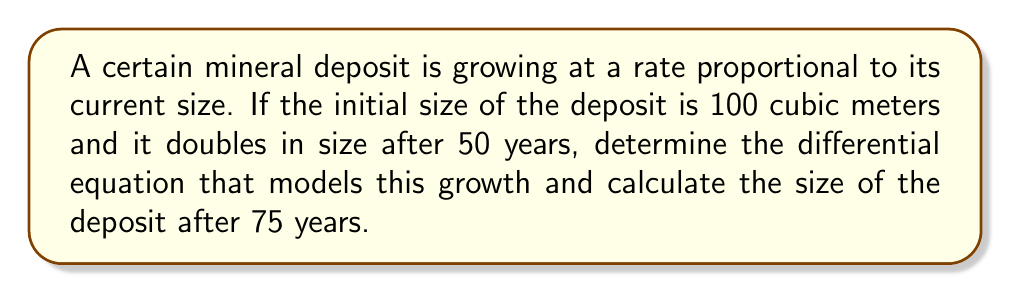Provide a solution to this math problem. Let's approach this step-by-step:

1) Let $V(t)$ be the volume of the deposit at time $t$ in years.

2) The growth rate is proportional to the current size, so we can write:

   $$\frac{dV}{dt} = kV$$

   where $k$ is the growth constant.

3) We know that $V(0) = 100$ (initial condition) and $V(50) = 200$ (doubles after 50 years).

4) The solution to this differential equation is:

   $$V(t) = V(0)e^{kt}$$

5) Using the condition at $t=50$:

   $$200 = 100e^{50k}$$

6) Solving for $k$:

   $$e^{50k} = 2$$
   $$50k = \ln(2)$$
   $$k = \frac{\ln(2)}{50}$$

7) Now we have the complete model:

   $$V(t) = 100e^{\frac{\ln(2)}{50}t}$$

8) To find the size after 75 years, we substitute $t=75$:

   $$V(75) = 100e^{\frac{\ln(2)}{50}(75)}$$

9) Simplifying:

   $$V(75) = 100e^{\frac{3}{2}\ln(2)} = 100(2^{\frac{3}{2}}) \approx 282.84$$
Answer: $V(t) = 100e^{\frac{\ln(2)}{50}t}$; $V(75) \approx 282.84$ cubic meters 